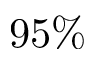Convert formula to latex. <formula><loc_0><loc_0><loc_500><loc_500>9 5 \%</formula> 